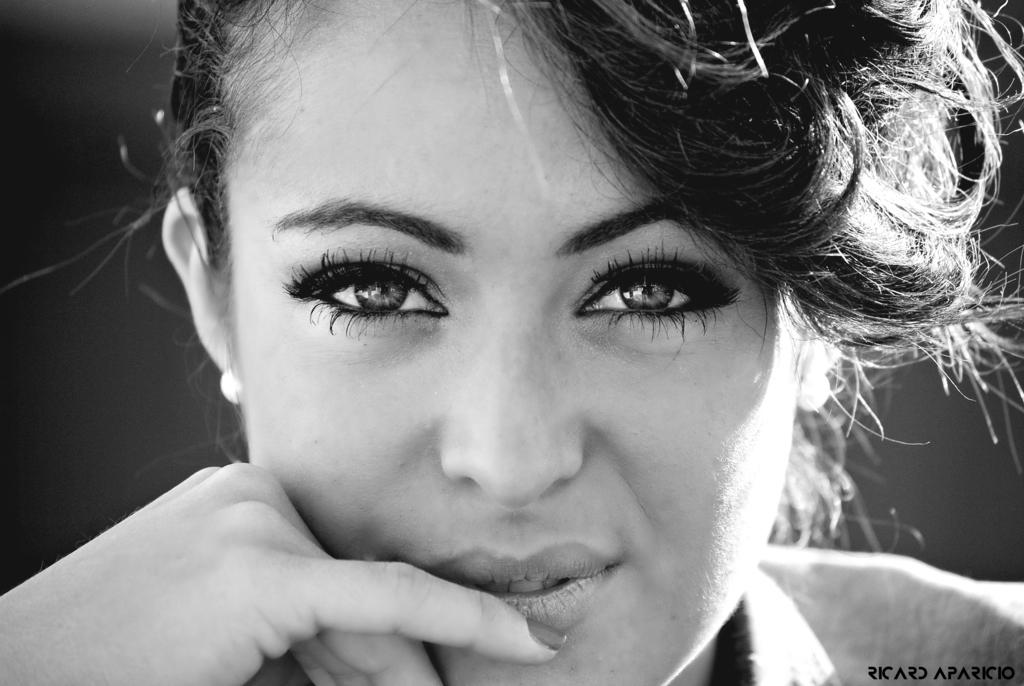What is the main subject of the image? There is a woman's face in the image. Can you describe the background of the image? The background of the image is blurred. What type of wheel can be seen in the market in the image? There is no wheel or market present in the image; it features a woman's face with a blurred background. What kind of coach is visible in the image? There is no coach present in the image; it features a woman's face with a blurred background. 